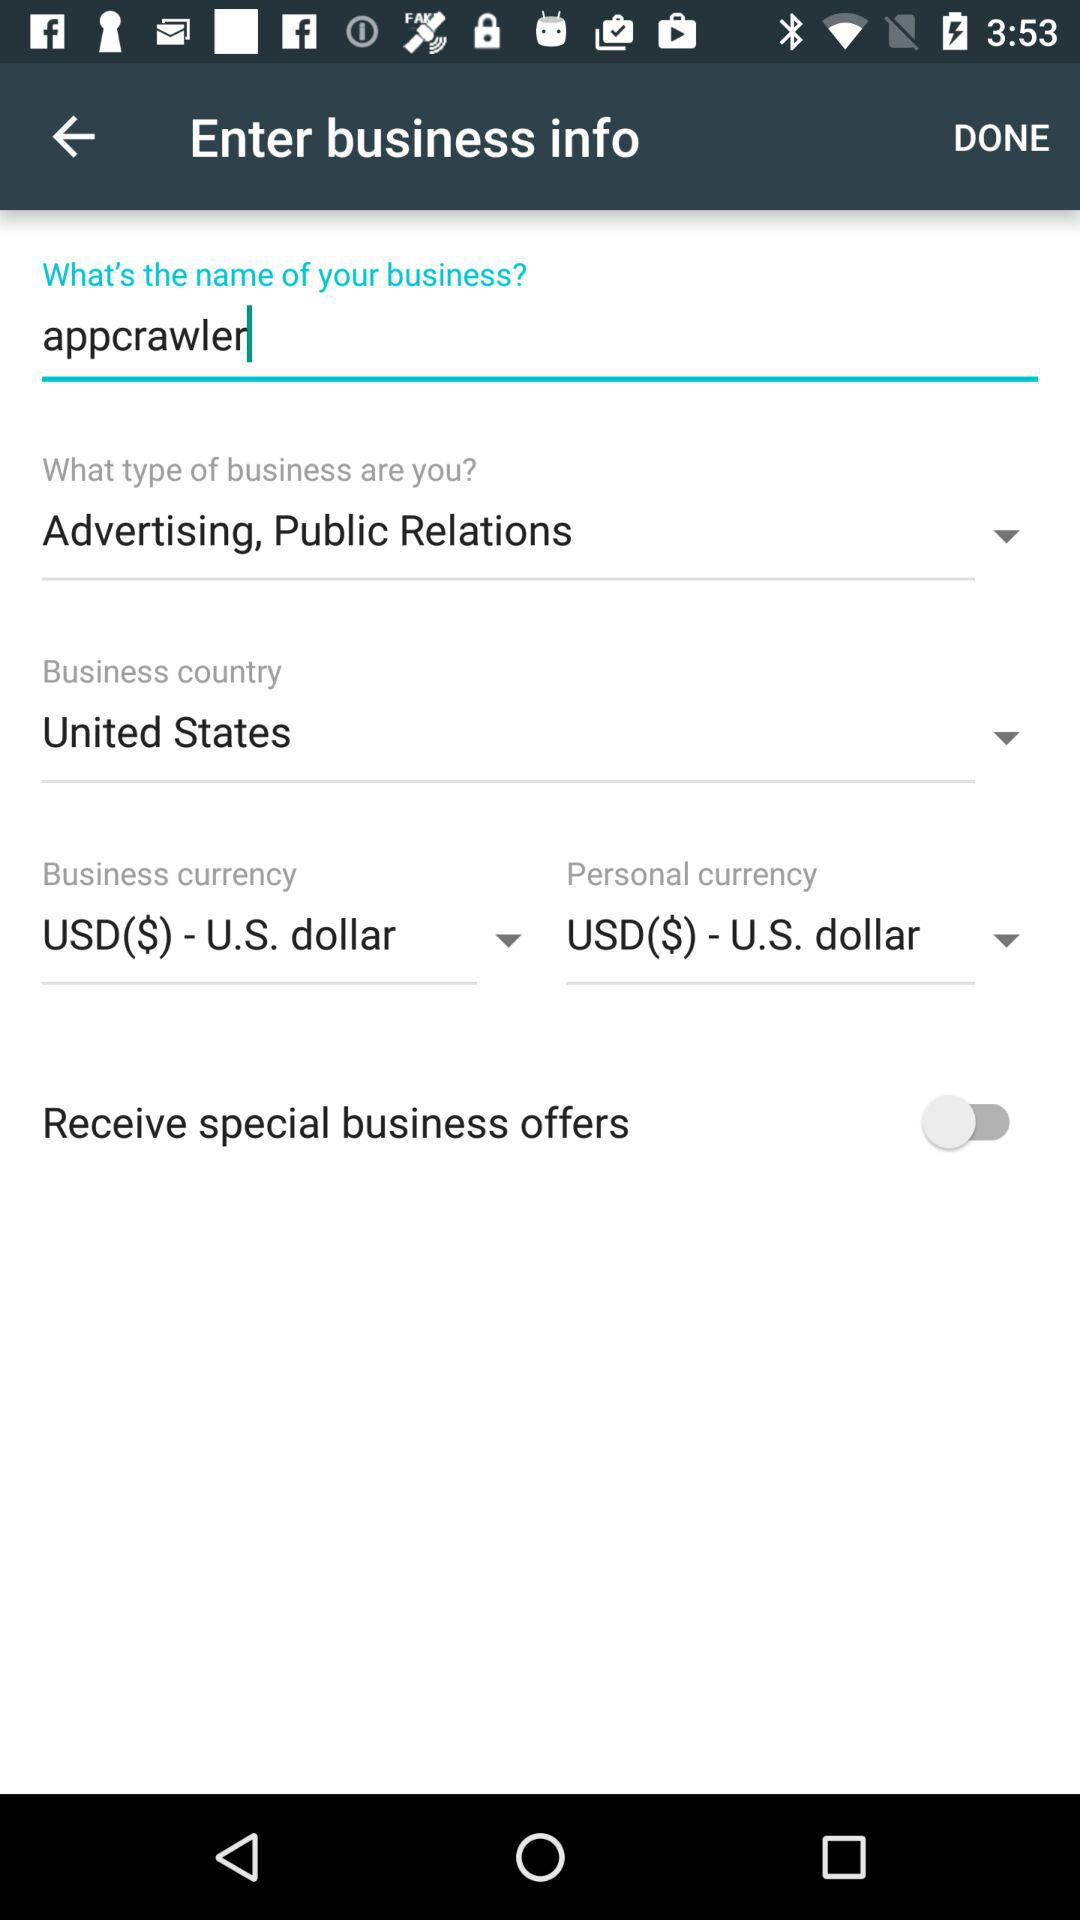What is the status of the "Receive special business offers"? The status of the "Receive special business offers" is "off". 